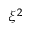Convert formula to latex. <formula><loc_0><loc_0><loc_500><loc_500>\xi ^ { 2 }</formula> 